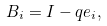Convert formula to latex. <formula><loc_0><loc_0><loc_500><loc_500>B _ { i } = I - q e _ { i } ,</formula> 